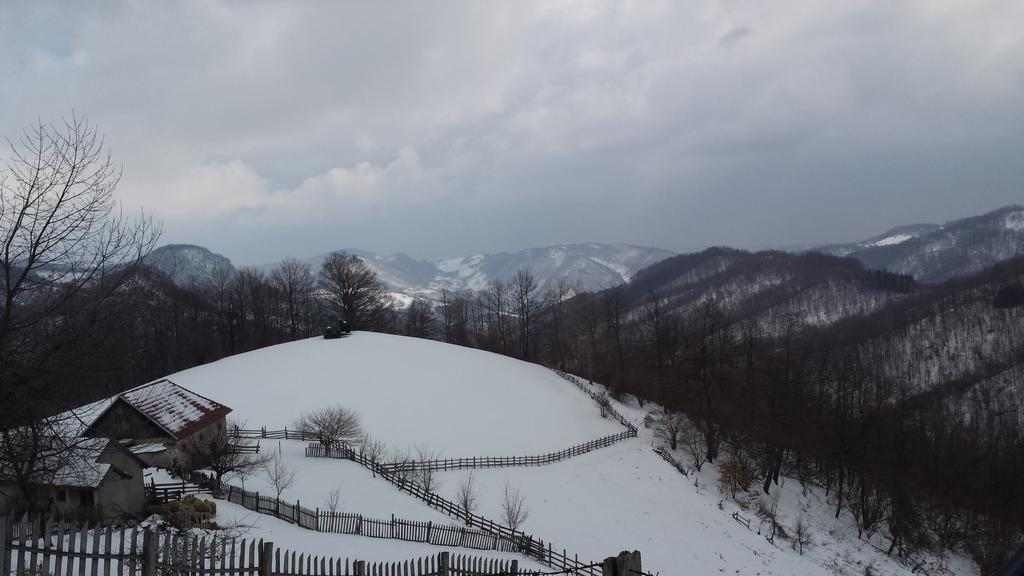What type of structures can be seen in the image? There are houses in the image. What natural elements are present in the image? There are trees and mountains in the image. What type of barrier can be seen in the image? There is fencing in the image. What weather condition is depicted in the image? The sky is cloudy in the image. What is the ground covered with in the image? There is snow visible in the image. What does the stomach of the tree in the image look like? There are no references to a tree's stomach in the image or in the provided facts. Trees do not have stomachs. Can you hear the voice of the mountain in the image? There are no voices or sounds mentioned in the image or in the provided facts. Mountains do not have voices. 